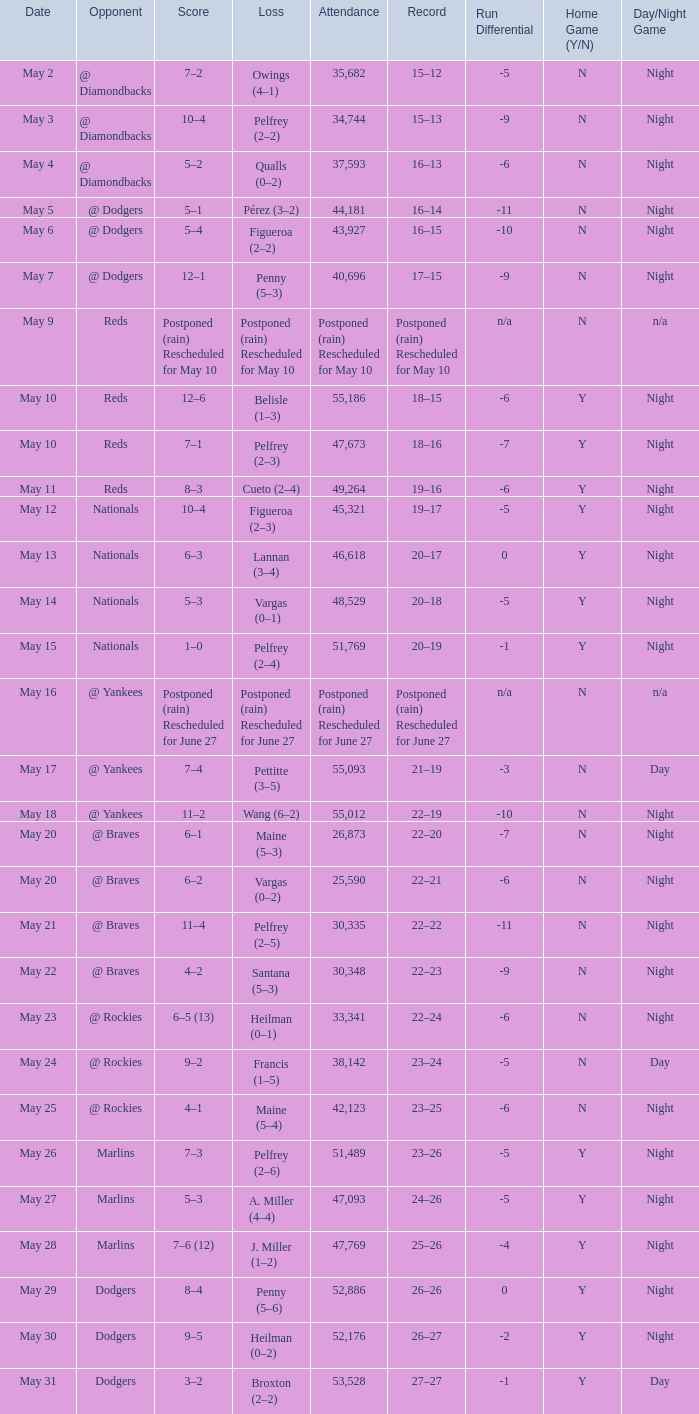Record of 22–20 involved what score? 6–1. 